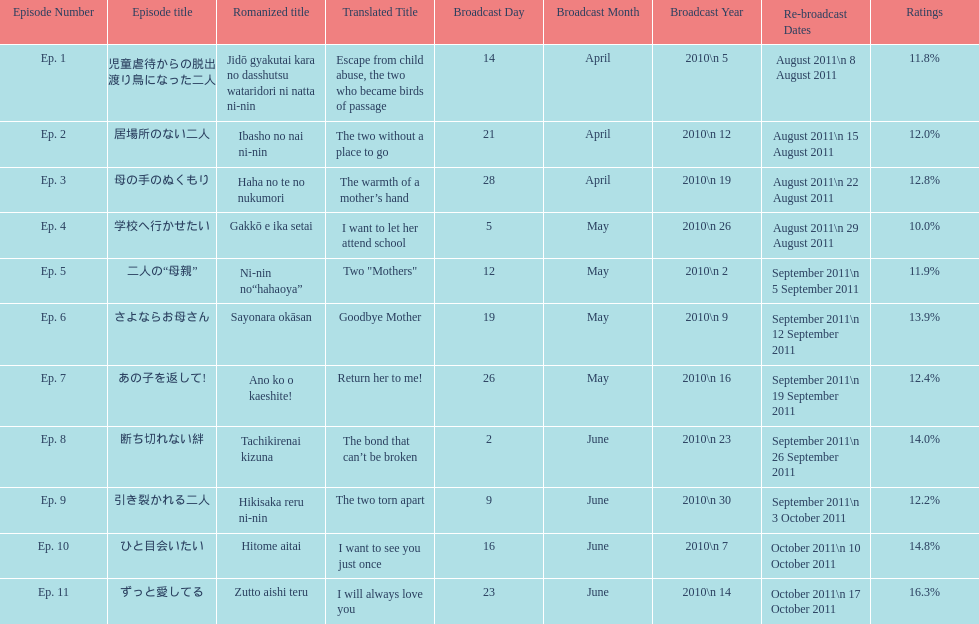Parse the table in full. {'header': ['Episode Number', 'Episode title', 'Romanized title', 'Translated Title', 'Broadcast Day', 'Broadcast Month', 'Broadcast Year', 'Re-broadcast Dates', 'Ratings'], 'rows': [['Ep. 1', '児童虐待からの脱出 渡り鳥になった二人', 'Jidō gyakutai kara no dasshutsu wataridori ni natta ni-nin', 'Escape from child abuse, the two who became birds of passage', '14', 'April', '2010\\n 5', 'August 2011\\n 8 August 2011', '11.8%'], ['Ep. 2', '居場所のない二人', 'Ibasho no nai ni-nin', 'The two without a place to go', '21', 'April', '2010\\n 12', 'August 2011\\n 15 August 2011', '12.0%'], ['Ep. 3', '母の手のぬくもり', 'Haha no te no nukumori', 'The warmth of a mother’s hand', '28', 'April', '2010\\n 19', 'August 2011\\n 22 August 2011', '12.8%'], ['Ep. 4', '学校へ行かせたい', 'Gakkō e ika setai', 'I want to let her attend school', '5', 'May', '2010\\n 26', 'August 2011\\n 29 August 2011', '10.0%'], ['Ep. 5', '二人の“母親”', 'Ni-nin no“hahaoya”', 'Two "Mothers"', '12', 'May', '2010\\n 2', 'September 2011\\n 5 September 2011', '11.9%'], ['Ep. 6', 'さよならお母さん', 'Sayonara okāsan', 'Goodbye Mother', '19', 'May', '2010\\n 9', 'September 2011\\n 12 September 2011', '13.9%'], ['Ep. 7', 'あの子を返して!', 'Ano ko o kaeshite!', 'Return her to me!', '26', 'May', '2010\\n 16', 'September 2011\\n 19 September 2011', '12.4%'], ['Ep. 8', '断ち切れない絆', 'Tachikirenai kizuna', 'The bond that can’t be broken', '2', 'June', '2010\\n 23', 'September 2011\\n 26 September 2011', '14.0%'], ['Ep. 9', '引き裂かれる二人', 'Hikisaka reru ni-nin', 'The two torn apart', '9', 'June', '2010\\n 30', 'September 2011\\n 3 October 2011', '12.2%'], ['Ep. 10', 'ひと目会いたい', 'Hitome aitai', 'I want to see you just once', '16', 'June', '2010\\n 7', 'October 2011\\n 10 October 2011', '14.8%'], ['Ep. 11', 'ずっと愛してる', 'Zutto aishi teru', 'I will always love you', '23', 'June', '2010\\n 14', 'October 2011\\n 17 October 2011', '16.3%']]} Which episode was titled i want to let her attend school? Ep. 4. 